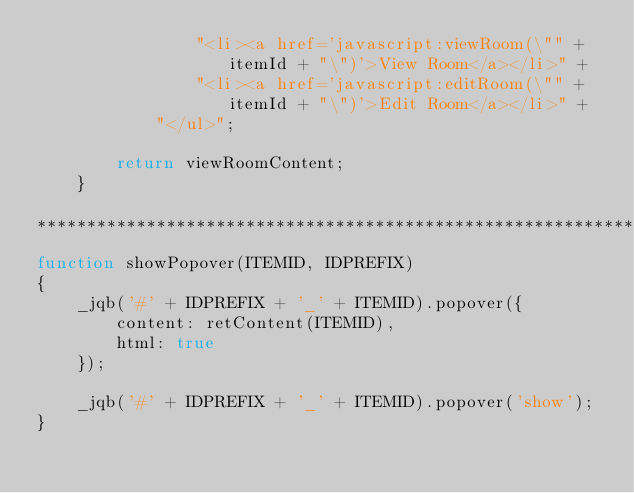<code> <loc_0><loc_0><loc_500><loc_500><_JavaScript_>                "<li><a href='javascript:viewRoom(\"" + itemId + "\")'>View Room</a></li>" + 
                "<li><a href='javascript:editRoom(\"" + itemId + "\")'>Edit Room</a></li>" + 
            "</ul>";

        return viewRoomContent;
    }

***********************************************************************************************/
function showPopover(ITEMID, IDPREFIX)
{
    _jqb('#' + IDPREFIX + '_' + ITEMID).popover({
        content: retContent(ITEMID),
        html: true
    });

    _jqb('#' + IDPREFIX + '_' + ITEMID).popover('show');
}

</code> 